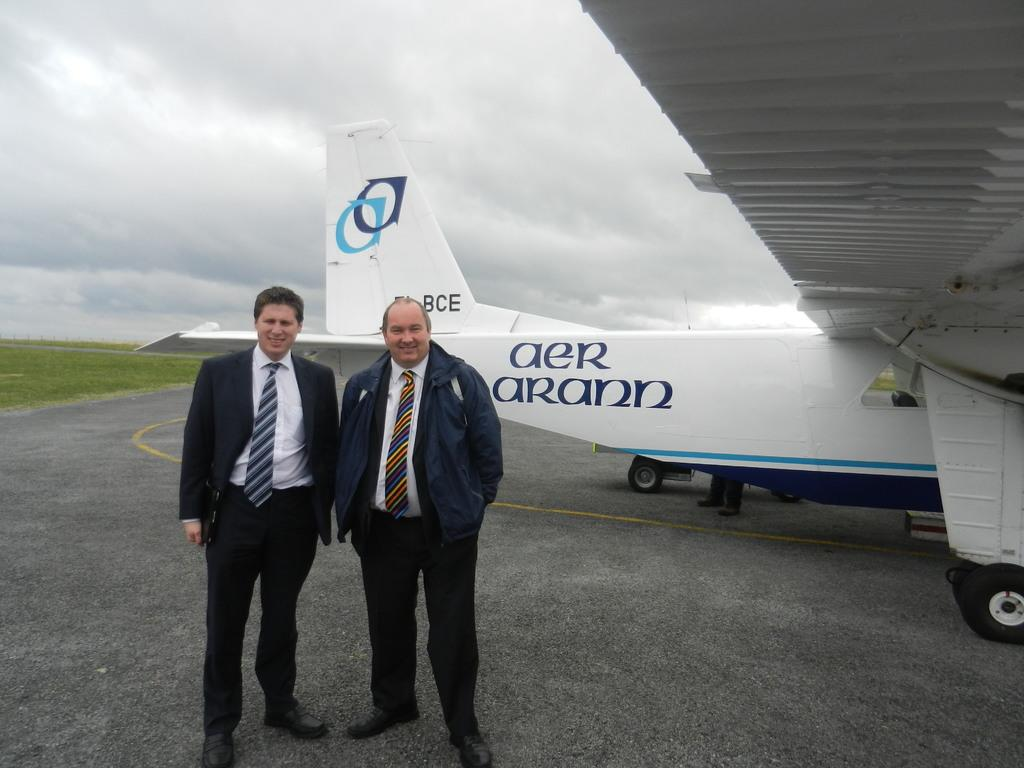<image>
Render a clear and concise summary of the photo. two men stand in front of an Aer Arann plane 